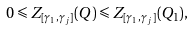<formula> <loc_0><loc_0><loc_500><loc_500>0 \leqslant Z _ { [ \gamma _ { 1 } , \gamma _ { j } ] } ( Q ) \leqslant Z _ { [ \gamma _ { 1 } , \gamma _ { j } ] } ( Q _ { 1 } ) ,</formula> 